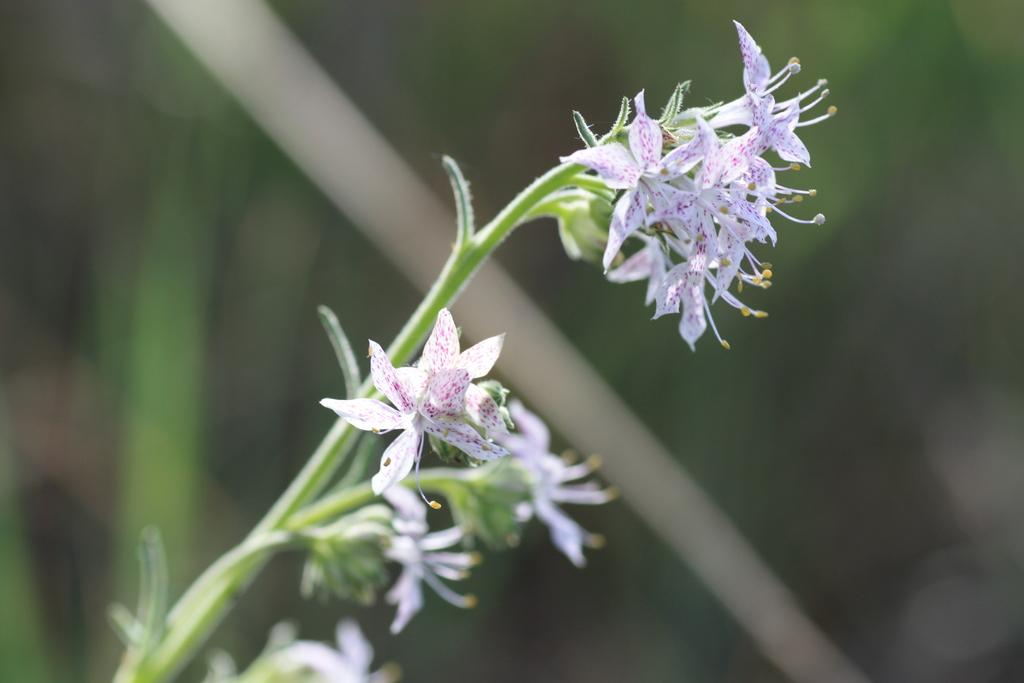What is the main subject of the image? The main subject of the image is a bunch of flowers. How are the flowers arranged in the image? The flowers are on a stem. What book is the squirrel reading in the image? There is no squirrel or book present in the image; it only features a bunch of flowers on a stem. 